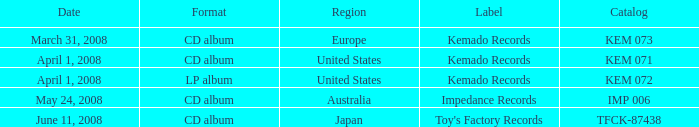Which Format has a Label of toy's factory records? CD album. 